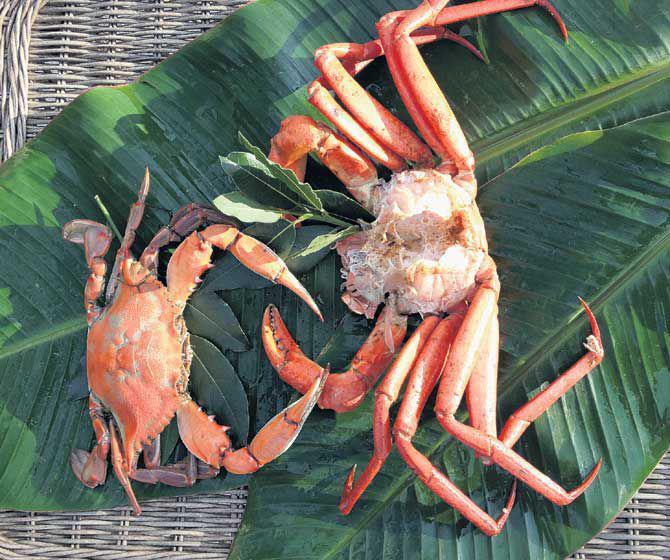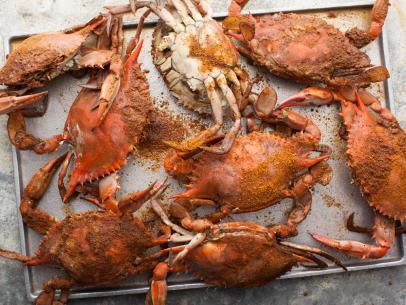The first image is the image on the left, the second image is the image on the right. Examine the images to the left and right. Is the description "There are two crabs next to each other." accurate? Answer yes or no. Yes. The first image is the image on the left, the second image is the image on the right. For the images shown, is this caption "No image contains more than two crabs, and no image features crabs that are prepared for eating." true? Answer yes or no. No. 